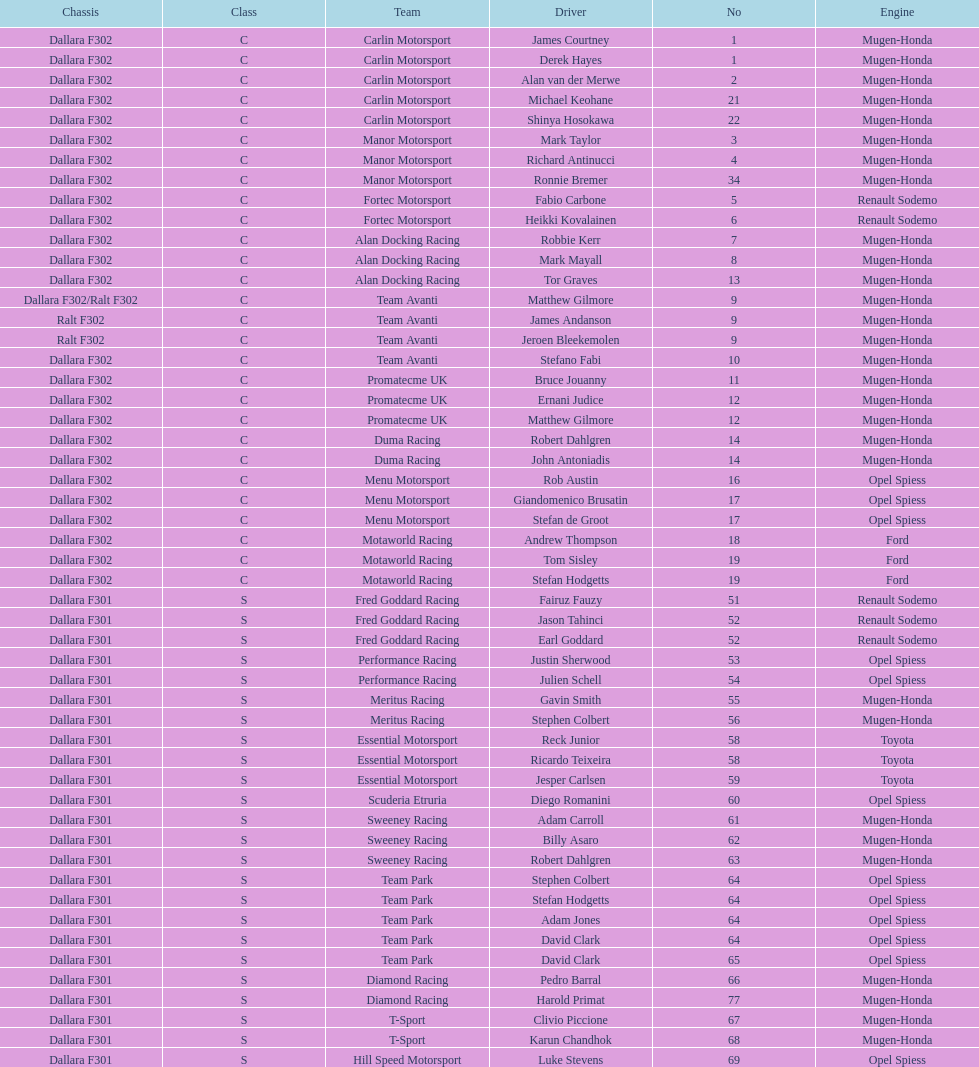How many teams had at least two drivers this season? 17. 